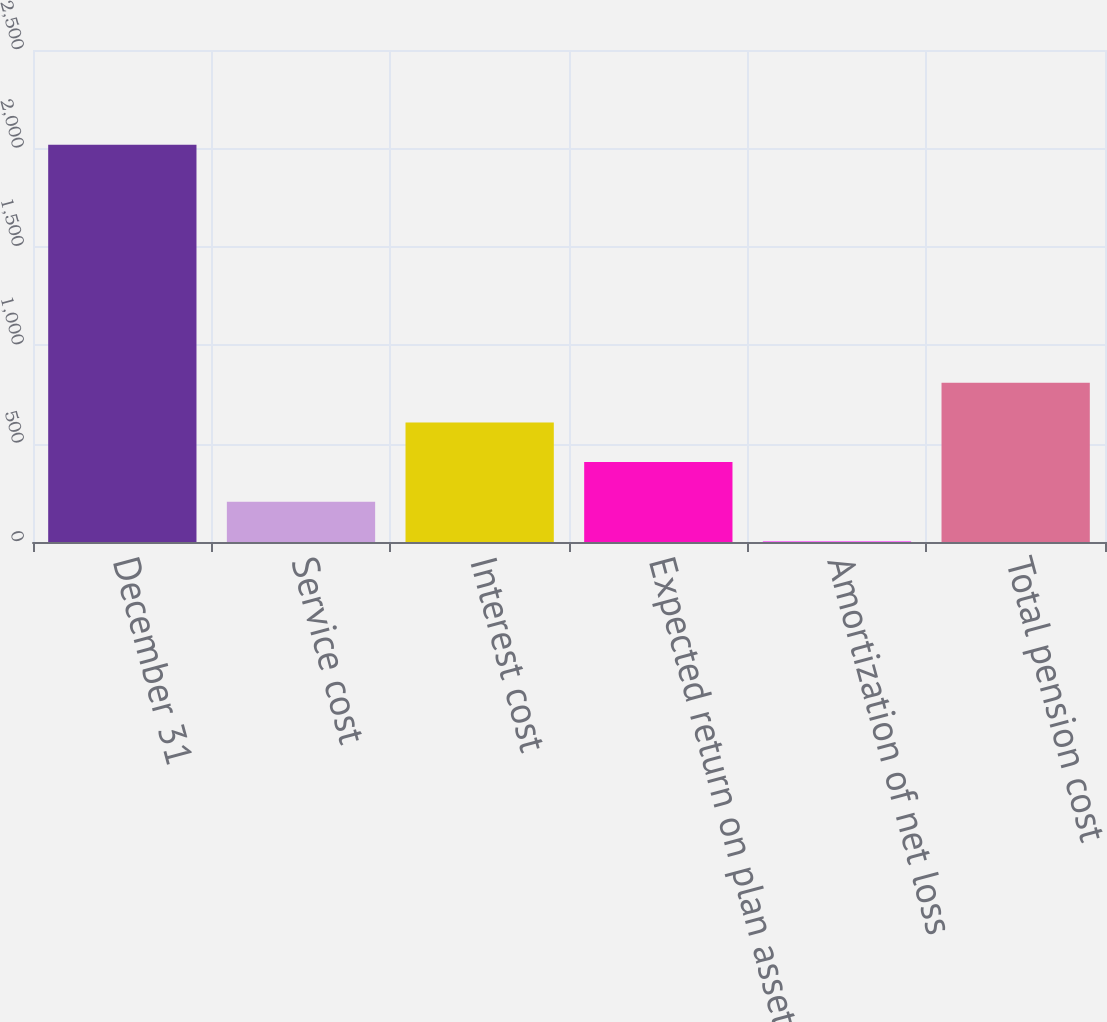Convert chart to OTSL. <chart><loc_0><loc_0><loc_500><loc_500><bar_chart><fcel>December 31<fcel>Service cost<fcel>Interest cost<fcel>Expected return on plan assets<fcel>Amortization of net loss<fcel>Total pension cost<nl><fcel>2018<fcel>204.5<fcel>607.5<fcel>406<fcel>3<fcel>809<nl></chart> 